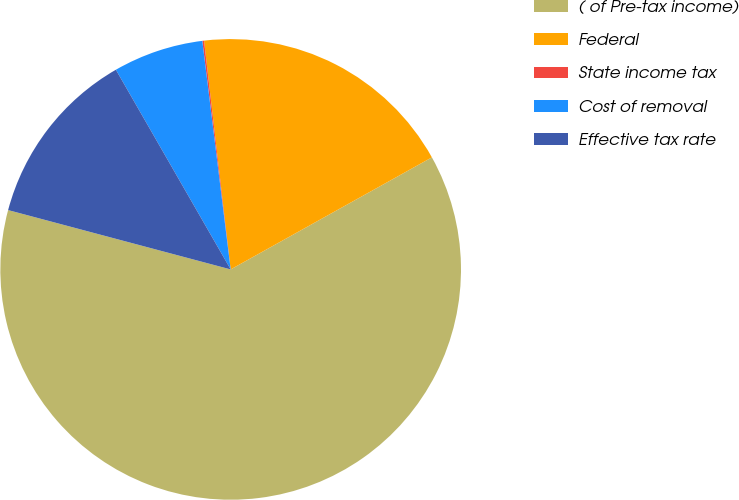Convert chart to OTSL. <chart><loc_0><loc_0><loc_500><loc_500><pie_chart><fcel>( of Pre-tax income)<fcel>Federal<fcel>State income tax<fcel>Cost of removal<fcel>Effective tax rate<nl><fcel>62.24%<fcel>18.76%<fcel>0.12%<fcel>6.34%<fcel>12.55%<nl></chart> 